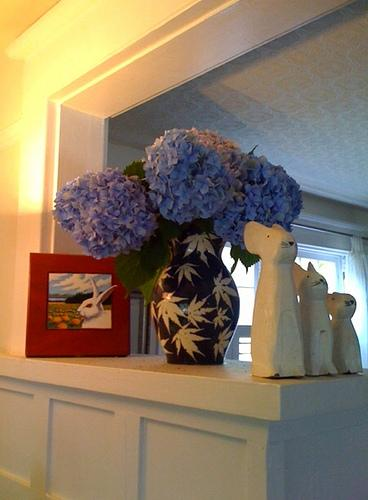What color is the wall mentioned in the image? The wall is white. Read the phrase written on the wall. There isn't any text on the wall. What color is the ceiling mentioned in the image? white Is the vase with flowers white and blue or black and white? Options: A) White and Blue; B) Black and White A) White and Blue Find any text on the picture frame. There isn't any text on the picture frame. Are the curtains on the side of the windows blue? The instructions describe the curtains as being sheer and white, so asking if the curtains are blue is misleading. Describe the relationship between the green leaves and the purple flowers. The green leaves and purple flowers are part of the same bouquet displayed in the blue and white vase on the shelf. What activity is being performed by the mice? There is no activity; they are wooden decorations. Explain how the white rabbits, the red picture frame, and the purple flowers are visually connected. All of them are part of the scene displayed on the white wooden shelf, with the red picture frame showcasing a painting of a rabbit in a field, while the purple flowers are in a nearby blue and white vase. Explain the relationship between the red picture frame and the purple flowers. The red picture frame encloses a painting of a rabbit in a field, while the purple flowers are nearby in a blue and white vase on the shelf. Is the picture frame green? The instructions mention a red picture frame, but there is no mention of a green picture frame, making this instruction misleading. Describe the setting: "In the room, the shelf displays a mix of beautiful objects." A white wooden shelf hosts items such as a blue and white vase with purple flowers, various white rabbits, a picture of a white rabbit in a field encased in a red frame alongside other decorations. Is there a yellow vase with white design in the image? The mentioned vase in the instructions is blue with a white design, not yellow, making this question misleading. Create a haiku depicting the scene portrayed in the image. White rabbits watch, Detect any ongoing celebration in the image. There isn't any ongoing celebration in the image. What action is happening in the picture? No action is happening; it's an image of a serene interior. Briefly describe the overall ambience of the room in the image, focusing on the shelf's contents. The room has a peaceful, serene environment with a white wooden shelf displaying various decorations such as white rabbits, a picture of a rabbit in a red frame, and a vase with purple flowers. What is the dominant color of the leaves in the vase? green Is there a picture of a black rabbit on the shelf? The instructions cite a picture of a white rabbit, not a black one, so this question is misleading. Do the purple flowers in the vase have yellow leaves? The instructions mention purple flowers with green leaves, so asking about yellow leaves is misleading. Are there five mice on the shelf? The instructions mention three mice, not five, which makes this question misleading. Which object is inside a red picture frame? a rabbit Write a short poem about the relationship between the rabbits and flowers in the image. Rabbits with flowers, friends of white, Identify an event taking place in the image. There isn't any event happening in the image. Describe the red frame on the shelf. The red frame is a picture frame surrounding a painting of a white rabbit in a field. 